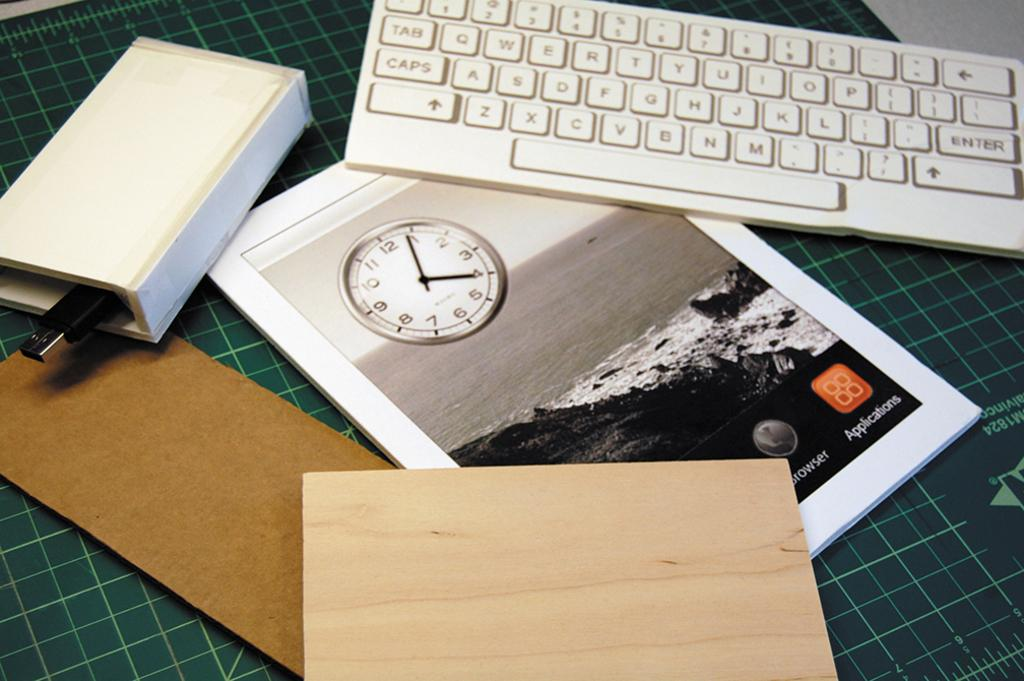<image>
Relay a brief, clear account of the picture shown. A keyboard, tablet and some other objects sit on a cutting board, the clock on the tablet showing 4:04. 